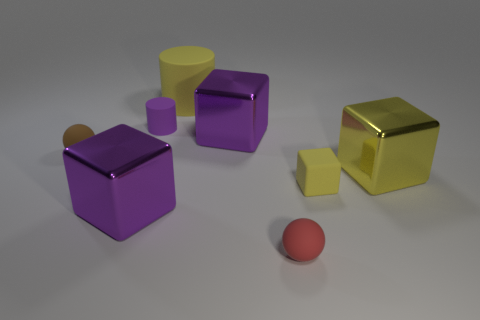The shiny object that is the same color as the large cylinder is what size?
Keep it short and to the point. Large. Are there any small cylinders that have the same material as the tiny red sphere?
Your answer should be compact. Yes. There is a purple cube that is left of the small purple rubber cylinder; what is it made of?
Provide a succinct answer. Metal. Do the large object on the right side of the small yellow thing and the large thing behind the tiny rubber cylinder have the same color?
Make the answer very short. Yes. What color is the cylinder that is the same size as the red object?
Provide a succinct answer. Purple. What number of other objects are there of the same shape as the small yellow thing?
Offer a very short reply. 3. There is a purple thing right of the big yellow matte thing; what size is it?
Keep it short and to the point. Large. How many cubes are right of the yellow object that is in front of the yellow metallic cube?
Keep it short and to the point. 1. What number of other objects are there of the same size as the red rubber thing?
Provide a succinct answer. 3. Is the tiny matte cube the same color as the large rubber cylinder?
Ensure brevity in your answer.  Yes. 